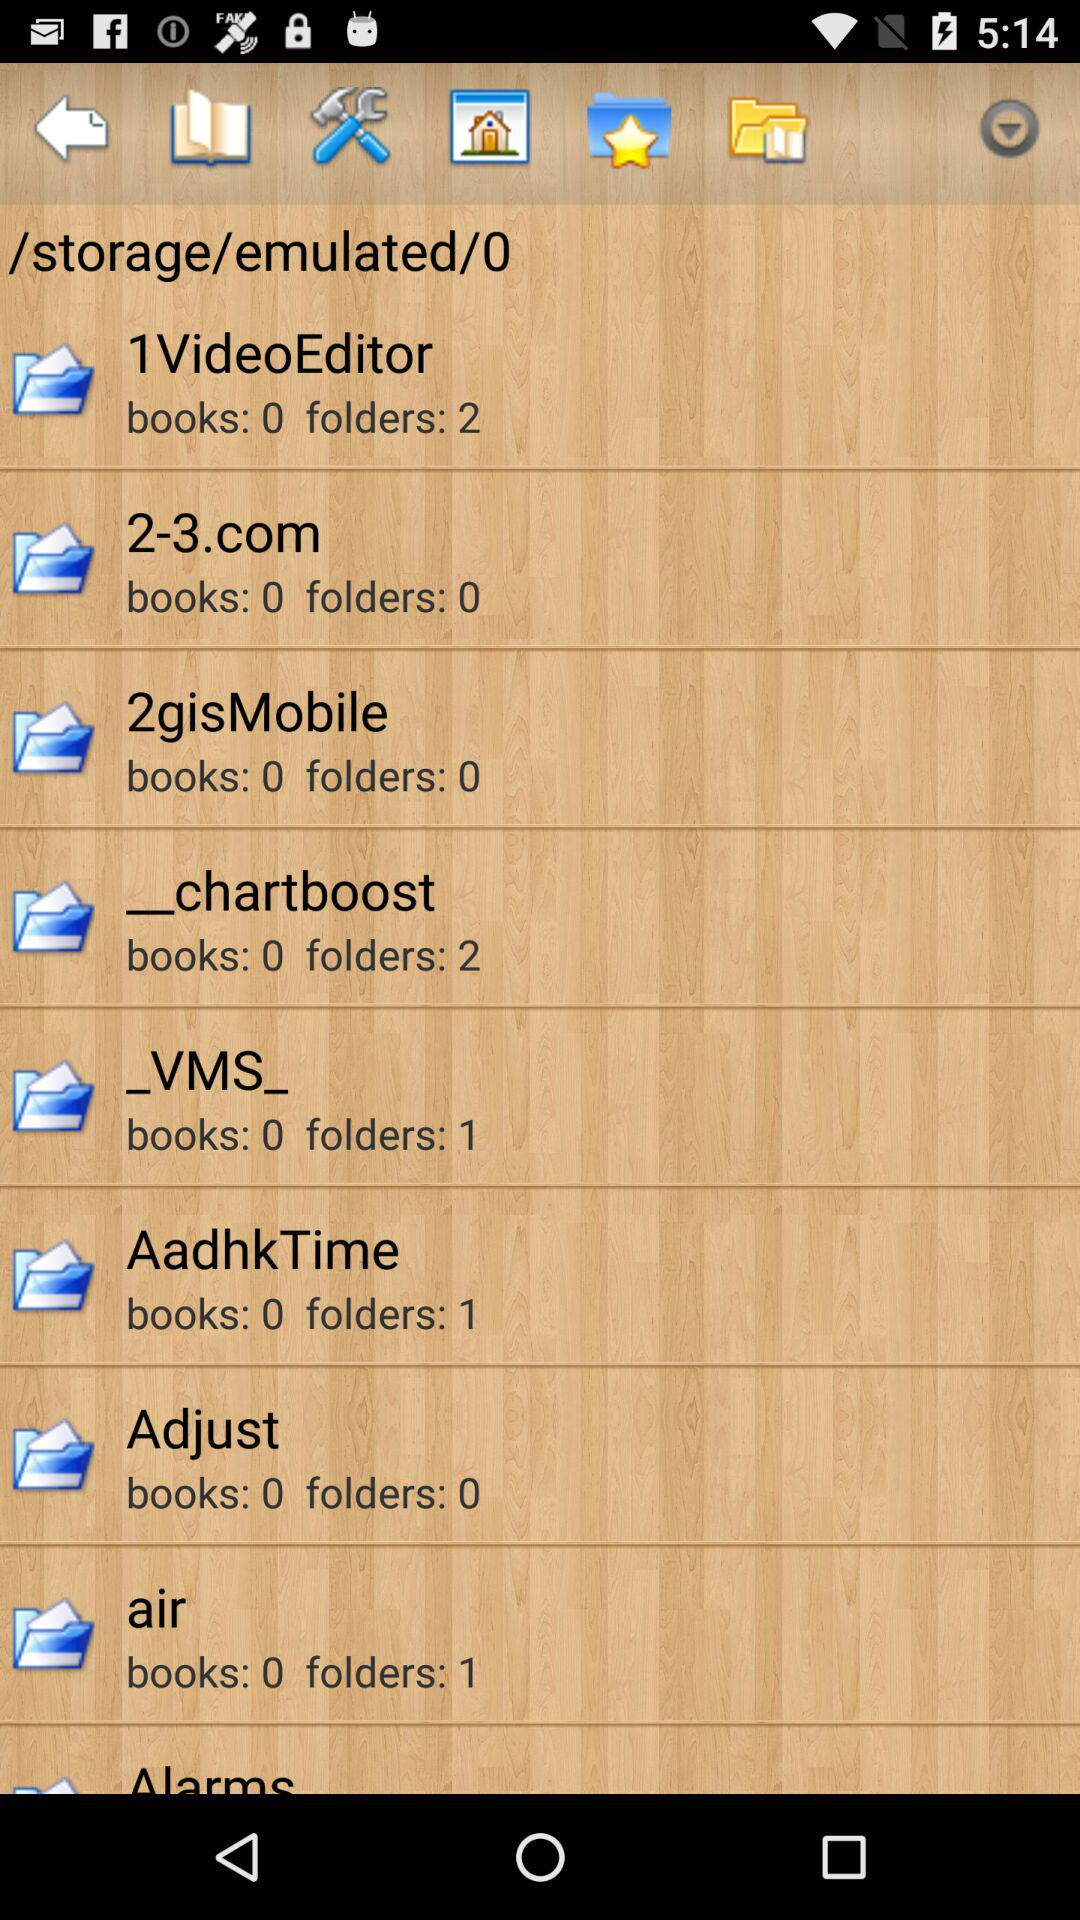How many books are there in the "_VMS_" folder? There are 0 books in the "_VMS_" folder. 